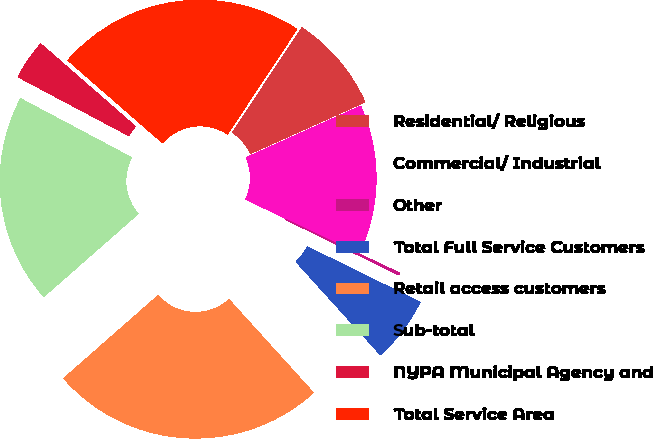<chart> <loc_0><loc_0><loc_500><loc_500><pie_chart><fcel>Residential/ Religious<fcel>Commercial/ Industrial<fcel>Other<fcel>Total Full Service Customers<fcel>Retail access customers<fcel>Sub-total<fcel>NYPA Municipal Agency and<fcel>Total Service Area<nl><fcel>8.97%<fcel>13.79%<fcel>0.2%<fcel>6.02%<fcel>25.25%<fcel>19.23%<fcel>3.65%<fcel>22.88%<nl></chart> 